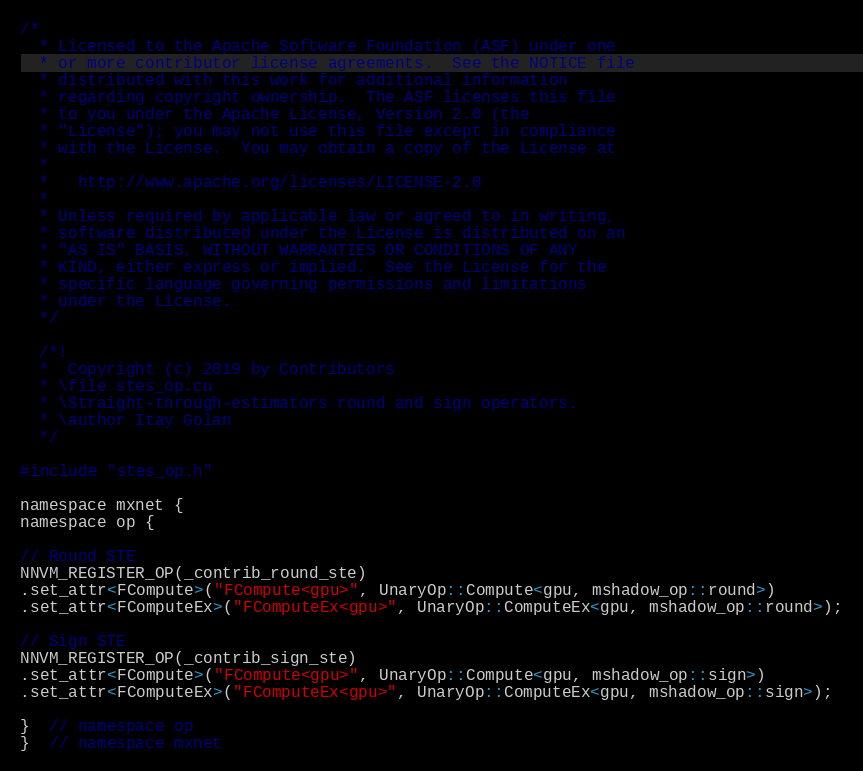Convert code to text. <code><loc_0><loc_0><loc_500><loc_500><_Cuda_>/*
  * Licensed to the Apache Software Foundation (ASF) under one
  * or more contributor license agreements.  See the NOTICE file
  * distributed with this work for additional information
  * regarding copyright ownership.  The ASF licenses this file
  * to you under the Apache License, Version 2.0 (the
  * "License"); you may not use this file except in compliance
  * with the License.  You may obtain a copy of the License at
  *
  *   http://www.apache.org/licenses/LICENSE-2.0
  *
  * Unless required by applicable law or agreed to in writing,
  * software distributed under the License is distributed on an
  * "AS IS" BASIS, WITHOUT WARRANTIES OR CONDITIONS OF ANY
  * KIND, either express or implied.  See the License for the
  * specific language governing permissions and limitations
  * under the License.
  */

  /*!
  *  Copyright (c) 2019 by Contributors
  * \file stes_op.cu
  * \Straight-through-estimators round and sign operators.
  * \author Itay Golan
  */

#include "stes_op.h"

namespace mxnet {
namespace op {

// Round STE
NNVM_REGISTER_OP(_contrib_round_ste)
.set_attr<FCompute>("FCompute<gpu>", UnaryOp::Compute<gpu, mshadow_op::round>)
.set_attr<FComputeEx>("FComputeEx<gpu>", UnaryOp::ComputeEx<gpu, mshadow_op::round>);

// Sign STE
NNVM_REGISTER_OP(_contrib_sign_ste)
.set_attr<FCompute>("FCompute<gpu>", UnaryOp::Compute<gpu, mshadow_op::sign>)
.set_attr<FComputeEx>("FComputeEx<gpu>", UnaryOp::ComputeEx<gpu, mshadow_op::sign>);

}  // namespace op
}  // namespace mxnet
</code> 